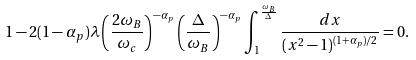Convert formula to latex. <formula><loc_0><loc_0><loc_500><loc_500>1 - 2 ( 1 - \alpha _ { p } ) \lambda \left ( \frac { 2 \omega _ { B } } { \omega _ { c } } \right ) ^ { - \alpha _ { p } } \left ( \frac { \Delta } { \omega _ { B } } \right ) ^ { - \alpha _ { p } } \int _ { 1 } ^ { \frac { \omega _ { B } } { \Delta } } \frac { d x } { ( x ^ { 2 } - 1 ) ^ { ( 1 + \alpha _ { p } ) / 2 } } = 0 .</formula> 